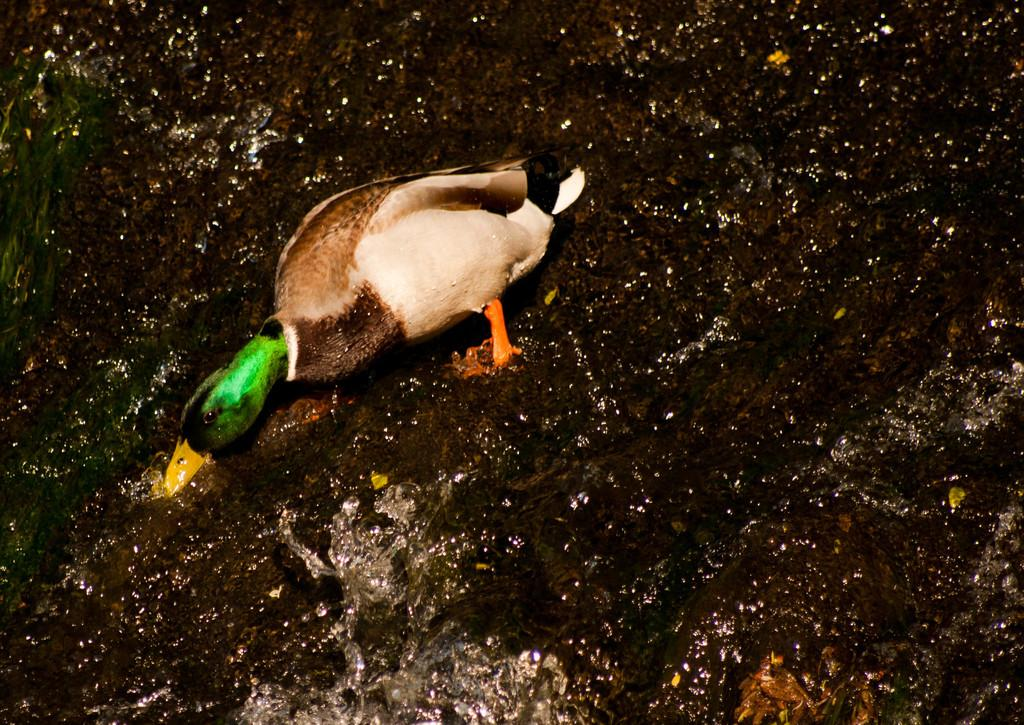What type of animal is present in the image? There is a bird in the image. What is the bird doing in the image? The bird is eating something in the image. Where is the bird located in the image? The bird is in the water in the image. What type of door can be seen in the image? There is no door present in the image; it features a bird in the water. 